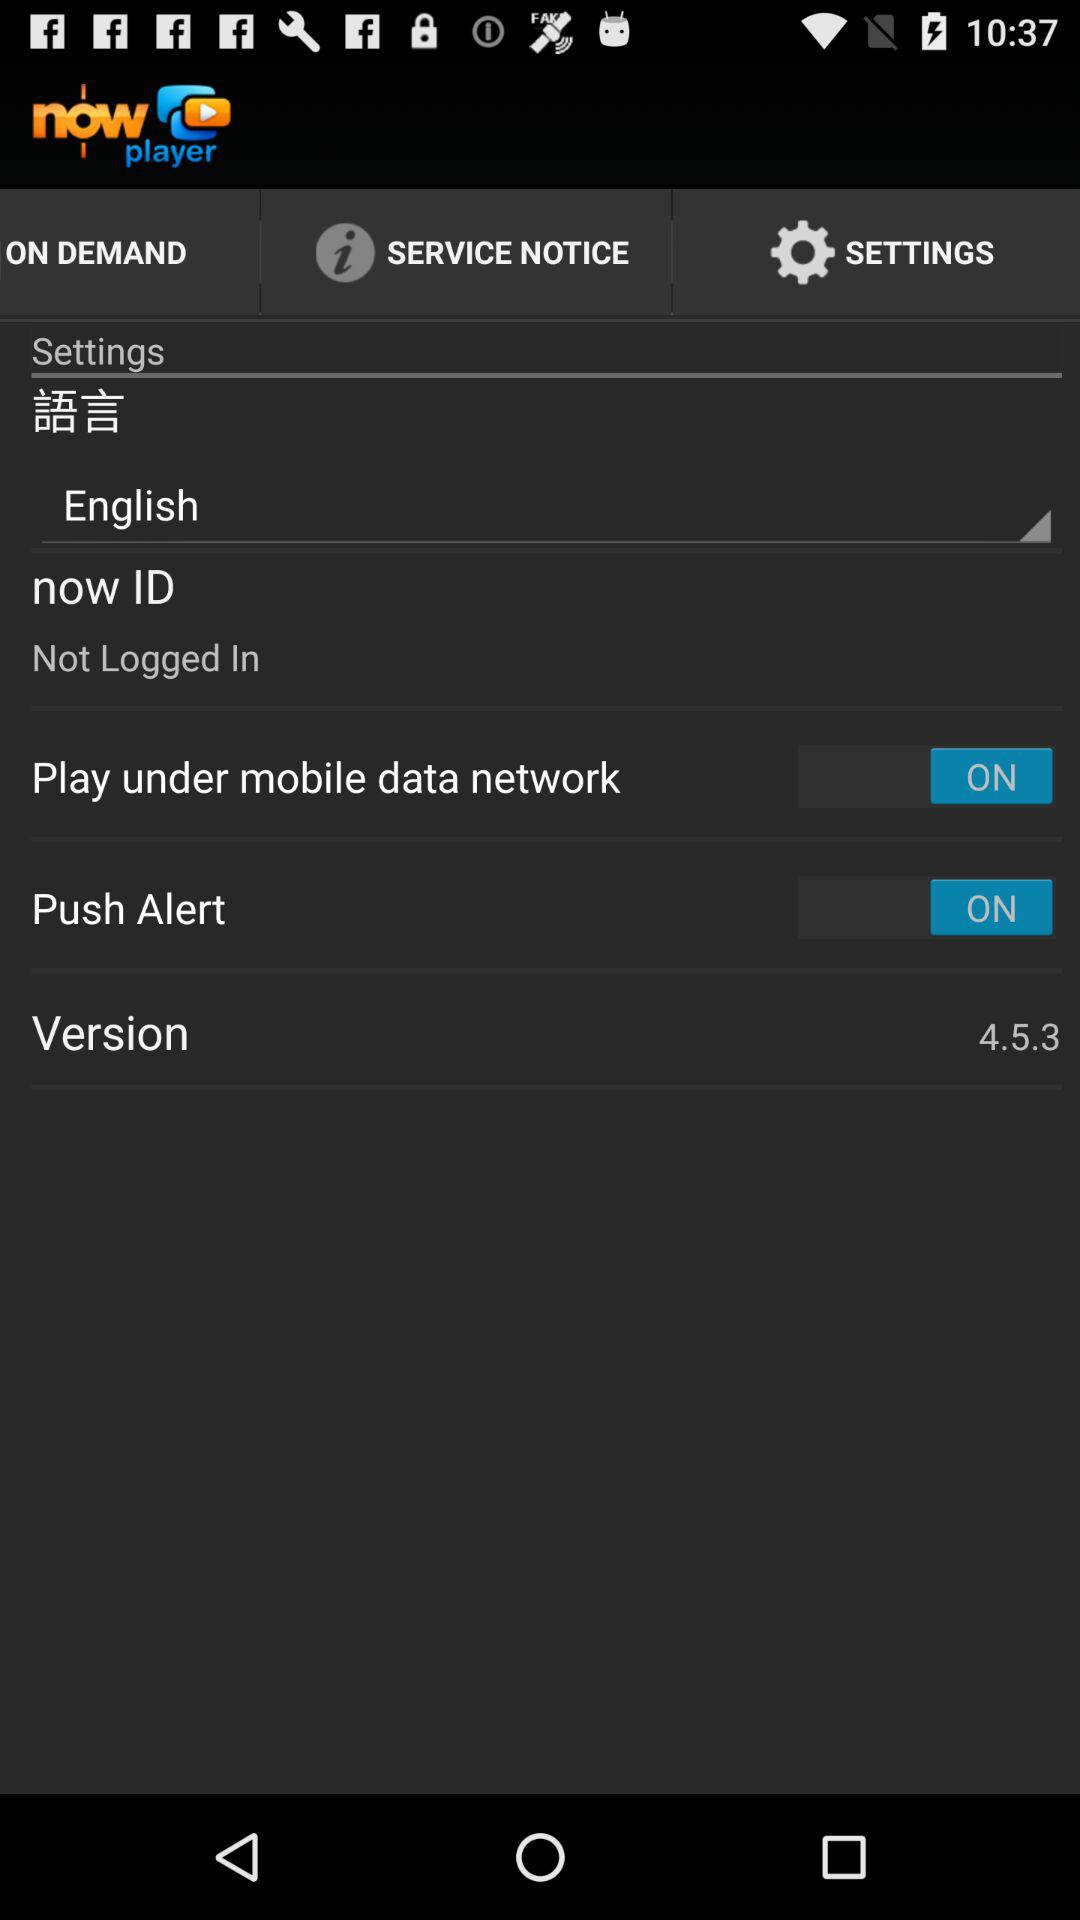What is the version of the app? The version is 4.5.3. 